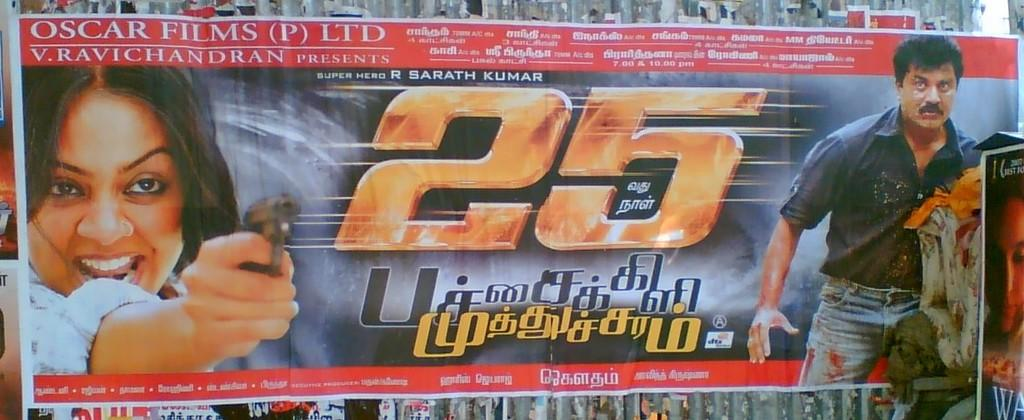What is the main subject in the center of the image? There is a poster in the center of the image. Where is the poster located? The poster is on a wall. What can be seen on the poster? There are depictions of a person on the poster. Are there any words on the poster? Yes, there is text on the poster. What type of cheese is being served by the maid on the poster? There is no maid or cheese present on the poster; it features depictions of a person and text. 